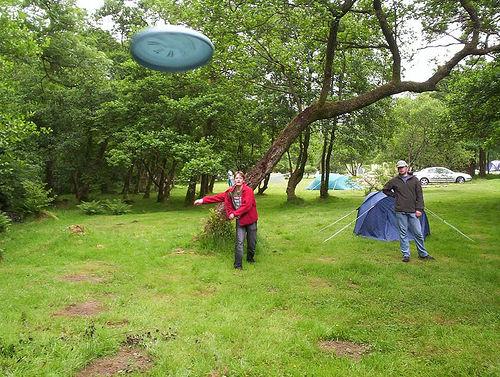What is being thrown?
Give a very brief answer. Frisbee. What color are the tents?
Answer briefly. Blue. Is it hot outside?
Keep it brief. No. 